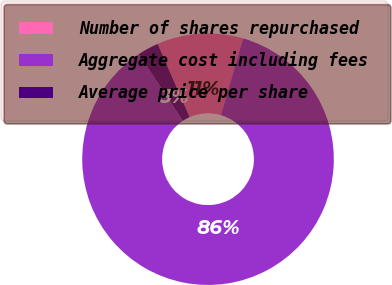<chart> <loc_0><loc_0><loc_500><loc_500><pie_chart><fcel>Number of shares repurchased<fcel>Aggregate cost including fees<fcel>Average price per share<nl><fcel>11.06%<fcel>86.22%<fcel>2.71%<nl></chart> 